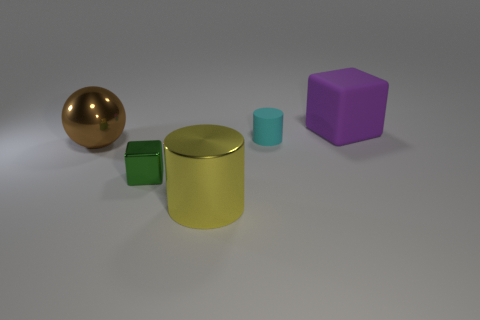Add 3 cylinders. How many objects exist? 8 Subtract all spheres. How many objects are left? 4 Subtract 2 cylinders. How many cylinders are left? 0 Add 5 small cyan things. How many small cyan things exist? 6 Subtract 0 gray cylinders. How many objects are left? 5 Subtract all purple cubes. Subtract all green cylinders. How many cubes are left? 1 Subtract all yellow blocks. How many cyan balls are left? 0 Subtract all large red objects. Subtract all large spheres. How many objects are left? 4 Add 4 rubber cubes. How many rubber cubes are left? 5 